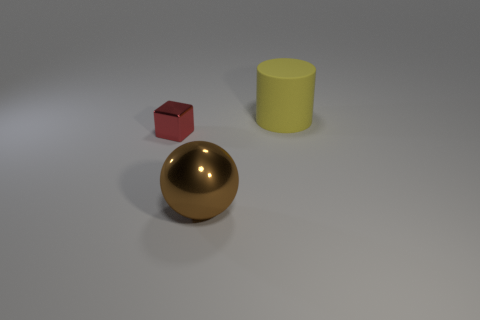Add 1 big yellow things. How many objects exist? 4 Subtract 1 cubes. How many cubes are left? 0 Subtract all big yellow cylinders. Subtract all spheres. How many objects are left? 1 Add 3 metal objects. How many metal objects are left? 5 Add 3 small cyan metal cylinders. How many small cyan metal cylinders exist? 3 Subtract 0 brown cubes. How many objects are left? 3 Subtract all cubes. How many objects are left? 2 Subtract all purple balls. Subtract all brown cubes. How many balls are left? 1 